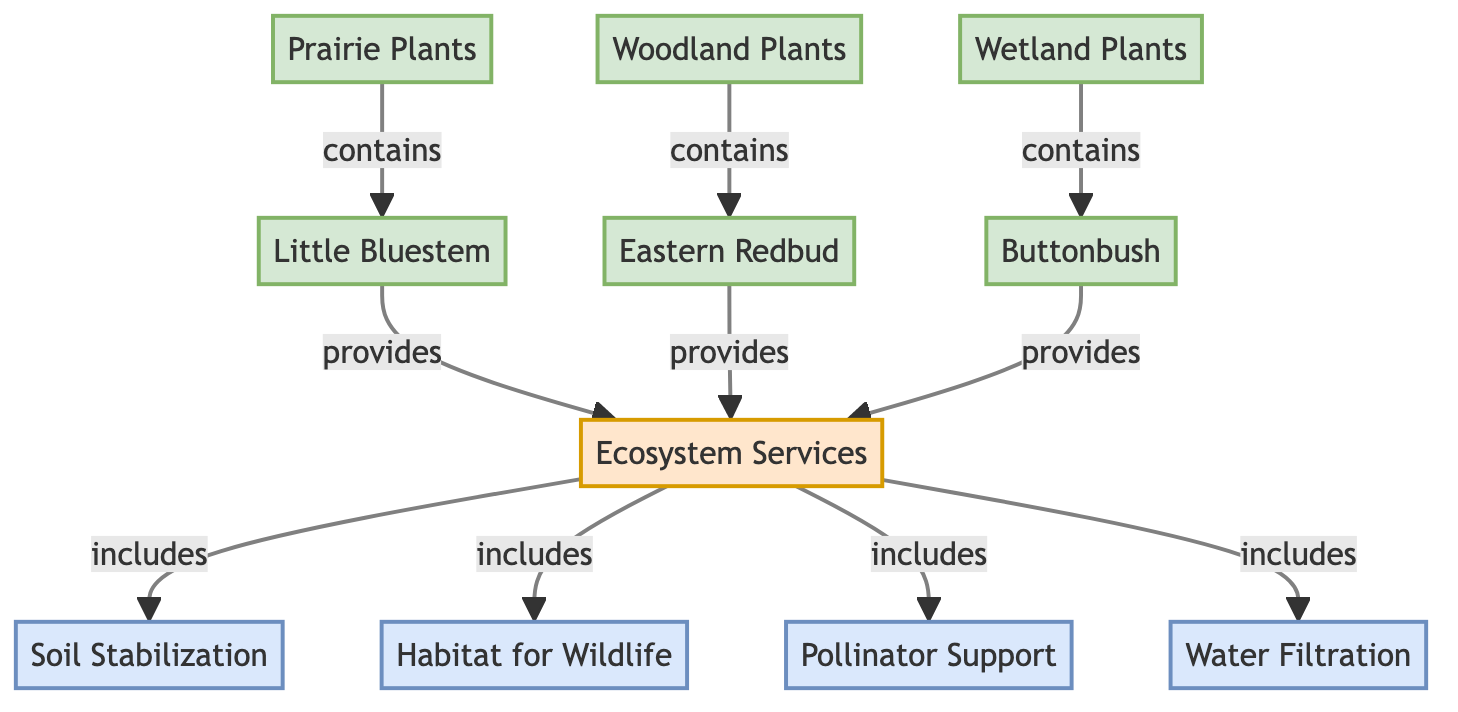What are the three types of plants depicted in the diagram? The diagram lists three types of plants: Prairie Plants, Woodland Plants, and Wetland Plants. These are shown as different nodes in the flowchart.
Answer: Prairie Plants, Woodland Plants, Wetland Plants Which plant is associated with the Woodland Plants category? The diagram indicates that the Eastern Redbud is associated with the Woodland Plants category, as it is connected to that node with an edge.
Answer: Eastern Redbud How many ecosystem services are included in the Ecosystem Services node? The Ecosystem Services node includes four services as indicated by the connections branching out to Soil Stabilization, Habitat for Wildlife, Pollinator Support, and Water Filtration.
Answer: 4 Which specific plant provides the Ecosystem Services? The diagram shows that all three types of plants (Prairie Plants, Woodland Plants, and Wetland Plants) provide Ecosystem Services, as they all have direct connections to the Ecosystem Services node.
Answer: Prairie Plants, Woodland Plants, Wetland Plants What is the relationship between Little Bluestem and Ecosystem Services? Little Bluestem is categorized under Prairie Plants and provides Ecosystem Services, as it is directly connected from the Prairie Plants node to the Ecosystem Services node.
Answer: provides Which plant species is linked to Water Filtration? According to the diagram, Water Filtration is one of the services provided by the Ecosystem Services node, which is connected to all three types of plants, meaning they all contribute to Water Filtration.
Answer: Prairie Plants, Woodland Plants, Wetland Plants What does the Ecosystem Services node encompass? The Ecosystem Services node encompasses multiple components including Soil Stabilization, Habitat for Wildlife, Pollinator Support, and Water Filtration as indicated by the connections it has to each of these service nodes.
Answer: Soil Stabilization, Habitat for Wildlife, Pollinator Support, Water Filtration How many plant species are identified in the diagram? There are three specific plant species identified in the diagram: Little Bluestem, Eastern Redbud, and Buttonbush, each associated with their respective plant types.
Answer: 3 What service is primarily linked to the Prairie Plants node? The diagram shows that the Prairie Plants node is linked to providing Ecosystem Services, which includes specific contributions like Soil Stabilization, Pollinator Support, etc.
Answer: provides Ecosystem Services 